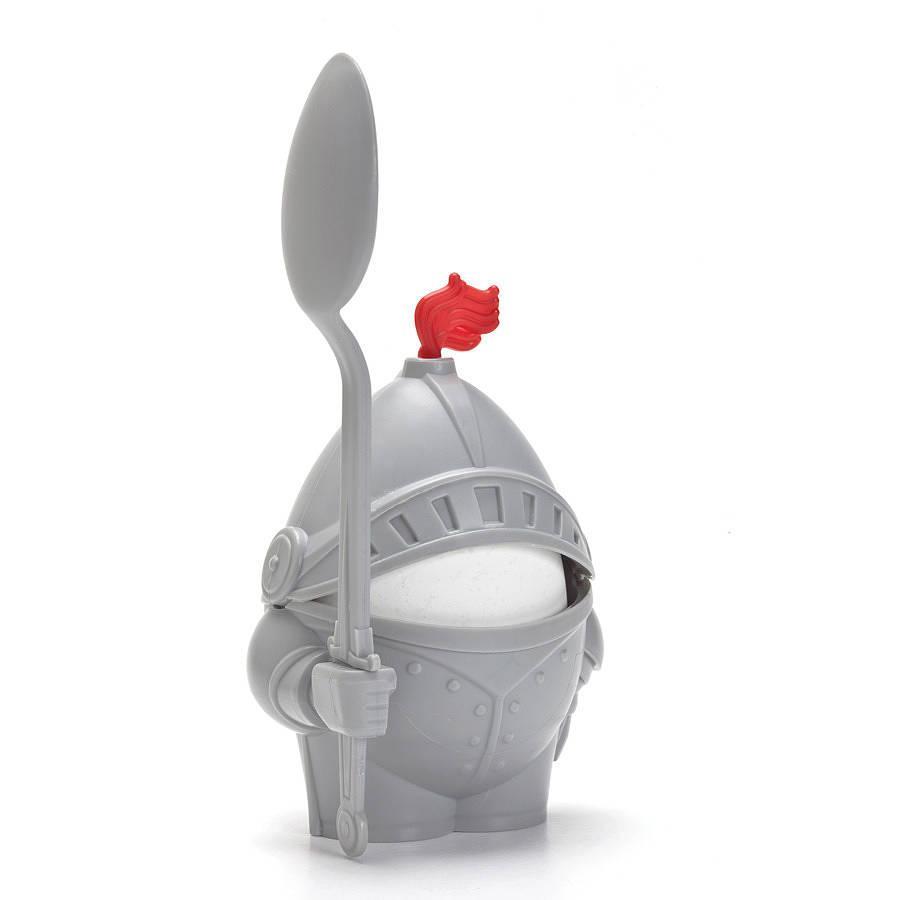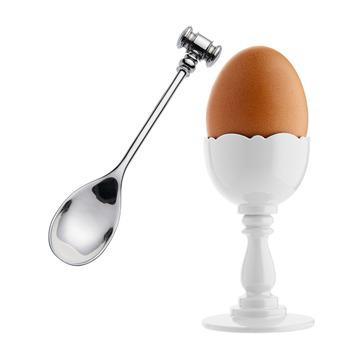The first image is the image on the left, the second image is the image on the right. Considering the images on both sides, is "The egg in the image on the right is brown." valid? Answer yes or no. Yes. 